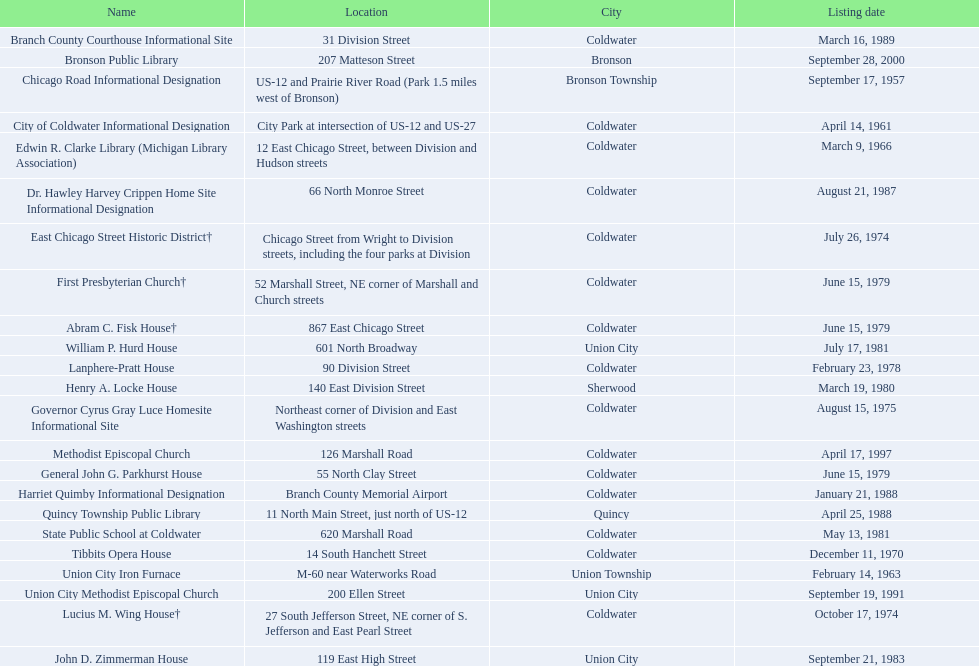Are there any listing dates that took place before 1960? September 17, 1957. What is the name of the site that was listed pre-1960? Chicago Road Informational Designation. Did any site listings occur prior to 1960? September 17, 1957. If so, what is the name of the site that was listed before 1960? Chicago Road Informational Designation. 